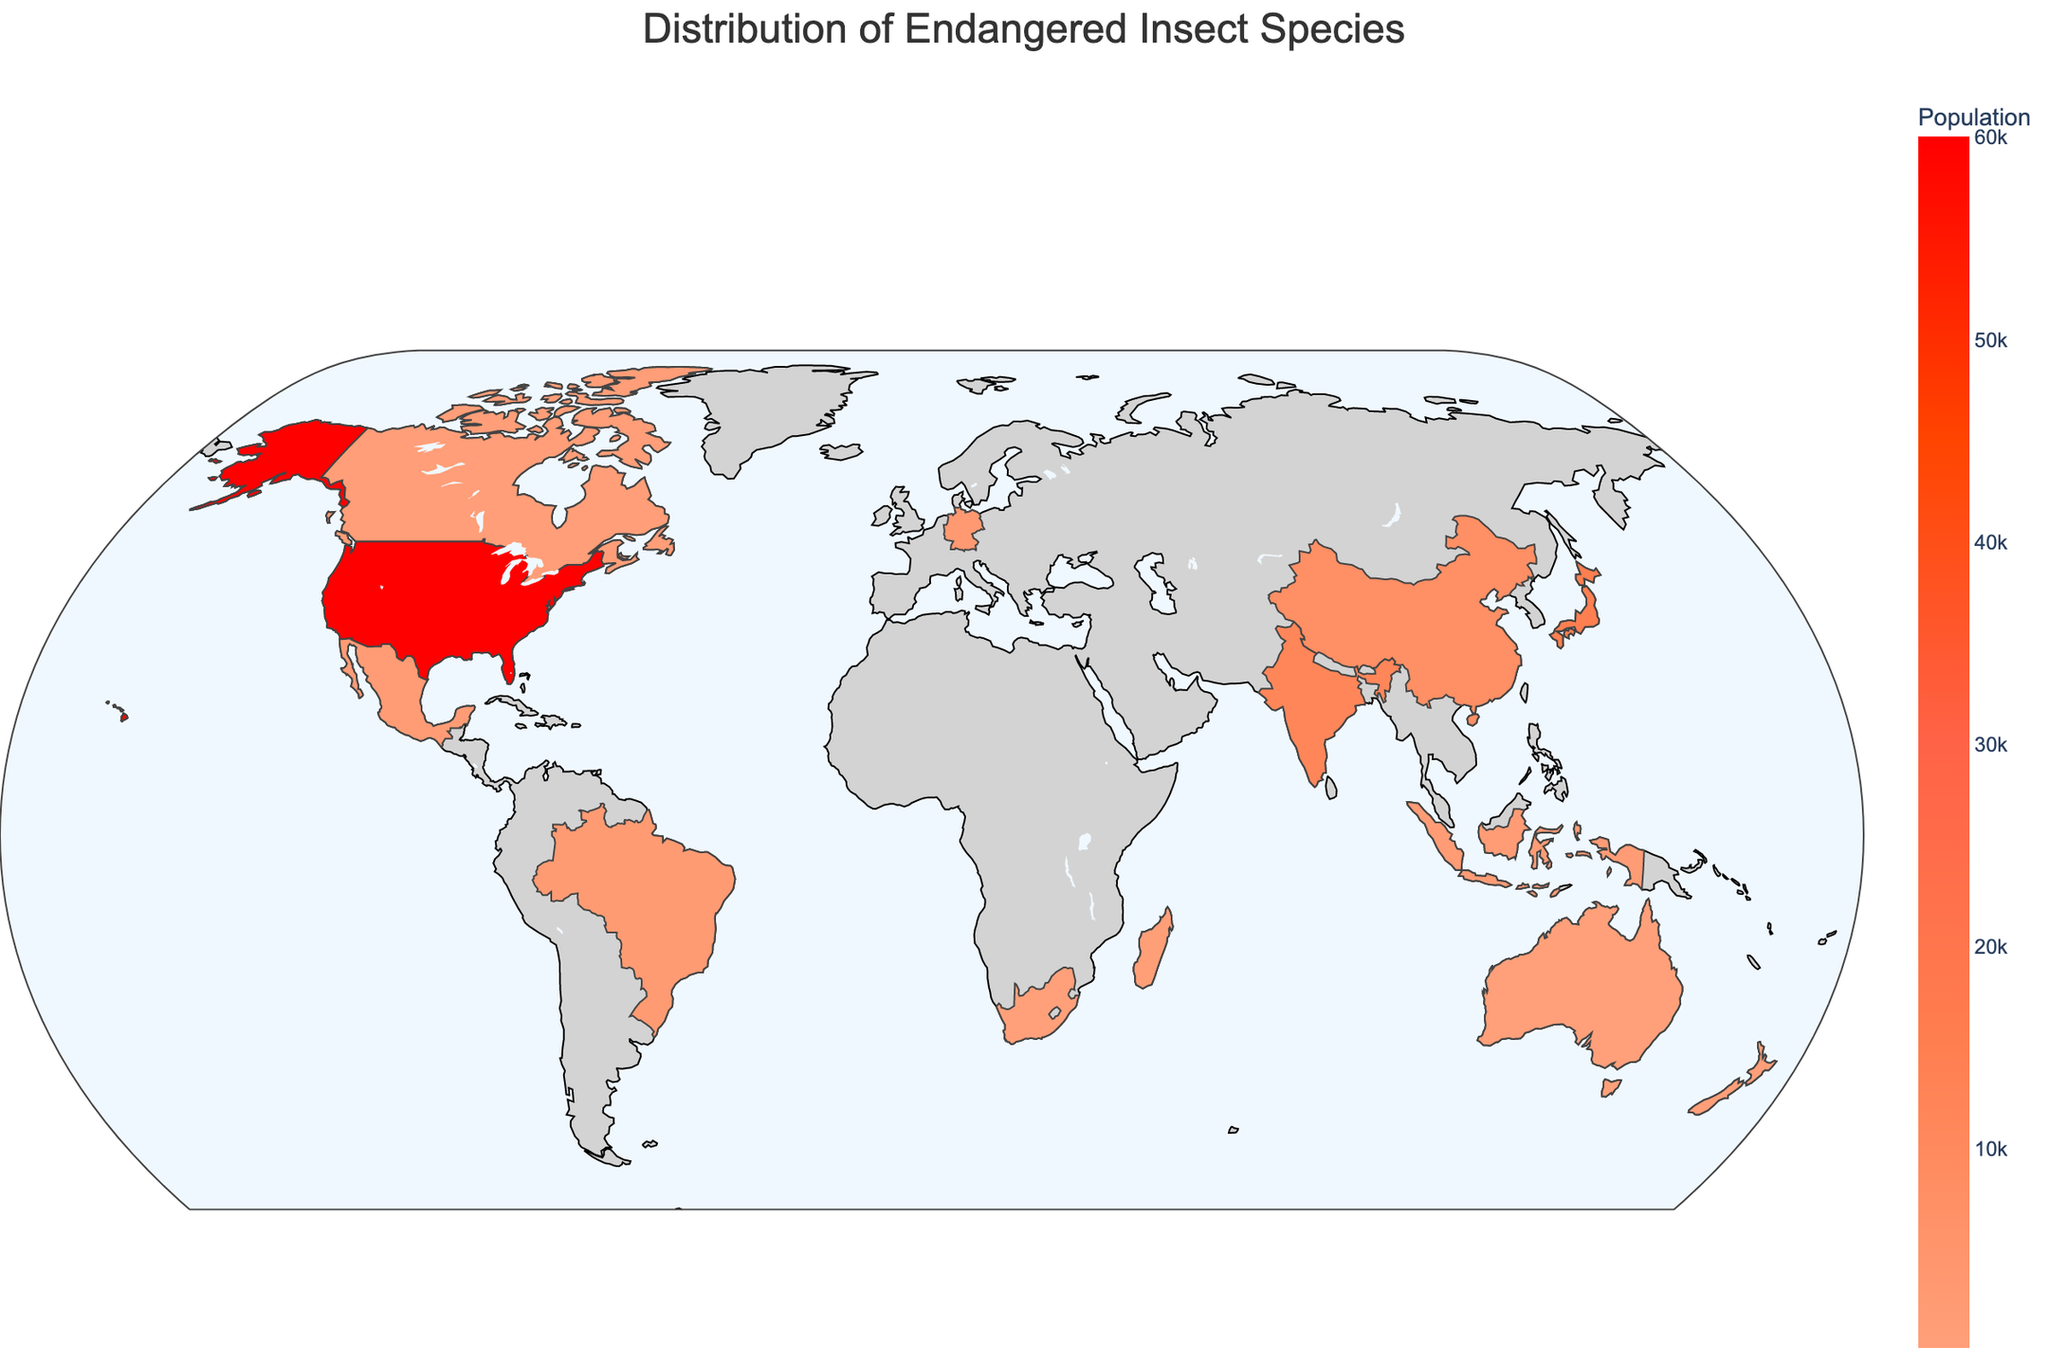What's the most populous endangered insect species in the United States? Look at the United States on the map and check the hover information. The Monarch butterfly has a population of 60,000 which is the highest listed.
Answer: Monarch butterfly Which country has the most critically endangered insect species? Examine the species labeled as Critically Endangered and their corresponding countries. The Lord Howe Island stick insect in Australia and the Colophon beetle in South Africa are the critically endangered species listed. Both have 1 critically endangered species each.
Answer: Australia and South Africa (tie) Compare the population of the endangered insect species in New Zealand and Canada, which one is higher? Check the populations for New Zealand (Weta bug, 600) and Canada (Rusty patched bumble bee, 1,000). Compare the two values to see which is greater.
Answer: Canada What is the combined population of all endangered species listed in the figure? Sum the population values of species with the 'Endangered' status: Monarch butterfly (60,000), Flatid leaf bug (800), Weta bug (600), Rusty patched bumble bee (1,000). The combined population is 60,000 + 800 + 600 + 1,000 = 62,400.
Answer: 62,400 In which country is Atlas moth listed, and what is its conservation status? Find Atlas moth in the hover information to see its country and status. Atlas moth is listed in India with a conservation status of Near Threatened.
Answer: India, Near Threatened What is the difference in population between the two critically endangered species listed? Look at the populations of the Lord Howe Island stick insect (150) and the Colophon beetle (200). The difference is 200 - 150 = 50.
Answer: 50 How many countries have insect species with a "Near Threatened" conservation status? Check the figure for countries with species labeled as Near Threatened. There are Japan (1), India (1), and China (1), totaling 3 countries.
Answer: 3 Is the conservation status of the Violet carpenter bee more or less concerning than Monarch butterfly? The Violet carpenter bee in Germany has a status of Vulnerable, while the Monarch butterfly in the United States has a status of Endangered. Endangered is more concerning than Vulnerable.
Answer: Less concerning Which has a larger population, Wallace's giant bee or Morpho butterfly? Compare the population for Wallace's giant bee (2000) and Morpho butterfly (2500). Morpho butterfly has a larger population.
Answer: Morpho butterfly What's the average population of Near Threatened species in this figure? Calculate the average by summing the populations of Luciola cruciata (15,000), Atlas moth (12,000), and Chinese moon moth (8,000) and then dividing by the number of such species (3). The sum is 35,000; the average is 35,000 / 3 = ~11,667.
Answer: ~11,667 